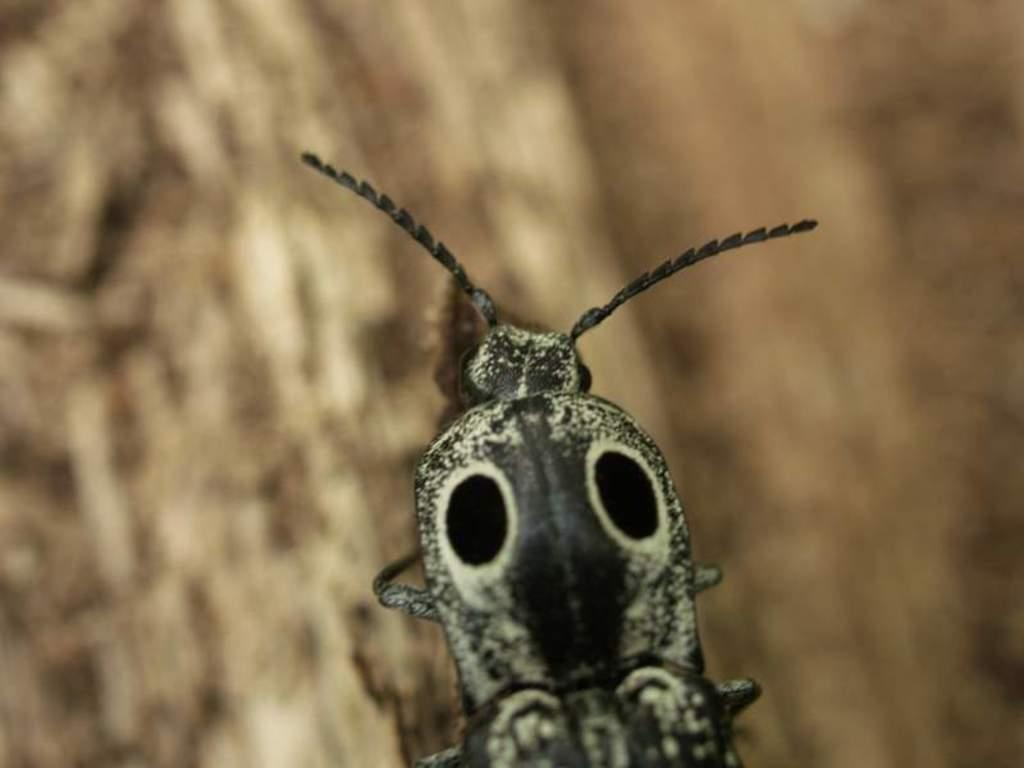What is the main subject in the foreground of the image? There is an insect in the foreground of the image. What color is the insect in the image? The insect is in black and white color. Can you describe the background of the image? The background of the image is blurry. What role does the goose play in the image? There is no goose present in the image. How does the father interact with the insect in the image? There is no father present in the image. 